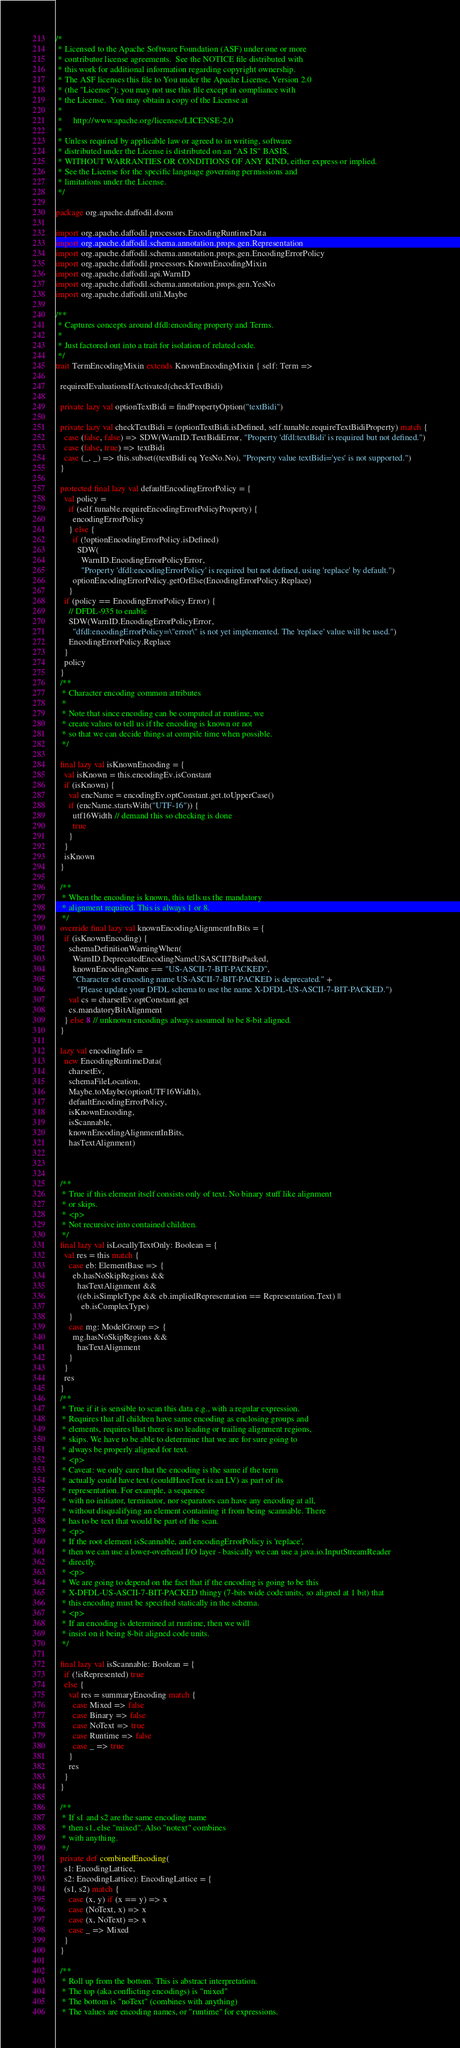<code> <loc_0><loc_0><loc_500><loc_500><_Scala_>/*
 * Licensed to the Apache Software Foundation (ASF) under one or more
 * contributor license agreements.  See the NOTICE file distributed with
 * this work for additional information regarding copyright ownership.
 * The ASF licenses this file to You under the Apache License, Version 2.0
 * (the "License"); you may not use this file except in compliance with
 * the License.  You may obtain a copy of the License at
 *
 *     http://www.apache.org/licenses/LICENSE-2.0
 *
 * Unless required by applicable law or agreed to in writing, software
 * distributed under the License is distributed on an "AS IS" BASIS,
 * WITHOUT WARRANTIES OR CONDITIONS OF ANY KIND, either express or implied.
 * See the License for the specific language governing permissions and
 * limitations under the License.
 */

package org.apache.daffodil.dsom

import org.apache.daffodil.processors.EncodingRuntimeData
import org.apache.daffodil.schema.annotation.props.gen.Representation
import org.apache.daffodil.schema.annotation.props.gen.EncodingErrorPolicy
import org.apache.daffodil.processors.KnownEncodingMixin
import org.apache.daffodil.api.WarnID
import org.apache.daffodil.schema.annotation.props.gen.YesNo
import org.apache.daffodil.util.Maybe

/**
 * Captures concepts around dfdl:encoding property and Terms.
 *
 * Just factored out into a trait for isolation of related code.
 */
trait TermEncodingMixin extends KnownEncodingMixin { self: Term =>

  requiredEvaluationsIfActivated(checkTextBidi)

  private lazy val optionTextBidi = findPropertyOption("textBidi")

  private lazy val checkTextBidi = (optionTextBidi.isDefined, self.tunable.requireTextBidiProperty) match {
    case (false, false) => SDW(WarnID.TextBidiError, "Property 'dfdl:textBidi' is required but not defined.")
    case (false, true) => textBidi
    case (_, _) => this.subset((textBidi eq YesNo.No), "Property value textBidi='yes' is not supported.")
  }

  protected final lazy val defaultEncodingErrorPolicy = {
    val policy =
      if (self.tunable.requireEncodingErrorPolicyProperty) {
        encodingErrorPolicy
      } else {
        if (!optionEncodingErrorPolicy.isDefined)
          SDW(
            WarnID.EncodingErrorPolicyError,
            "Property 'dfdl:encodingErrorPolicy' is required but not defined, using 'replace' by default.")
        optionEncodingErrorPolicy.getOrElse(EncodingErrorPolicy.Replace)
      }
    if (policy == EncodingErrorPolicy.Error) {
      // DFDL-935 to enable
      SDW(WarnID.EncodingErrorPolicyError,
        "dfdl:encodingErrorPolicy=\"error\" is not yet implemented. The 'replace' value will be used.")
      EncodingErrorPolicy.Replace
    }
    policy
  }
  /**
   * Character encoding common attributes
   *
   * Note that since encoding can be computed at runtime, we
   * create values to tell us if the encoding is known or not
   * so that we can decide things at compile time when possible.
   */

  final lazy val isKnownEncoding = {
    val isKnown = this.encodingEv.isConstant
    if (isKnown) {
      val encName = encodingEv.optConstant.get.toUpperCase()
      if (encName.startsWith("UTF-16")) {
        utf16Width // demand this so checking is done
        true
      }
    }
    isKnown
  }

  /**
   * When the encoding is known, this tells us the mandatory
   * alignment required. This is always 1 or 8.
   */
  override final lazy val knownEncodingAlignmentInBits = {
    if (isKnownEncoding) {
      schemaDefinitionWarningWhen(
        WarnID.DeprecatedEncodingNameUSASCII7BitPacked,
        knownEncodingName == "US-ASCII-7-BIT-PACKED",
        "Character set encoding name US-ASCII-7-BIT-PACKED is deprecated." +
          "Please update your DFDL schema to use the name X-DFDL-US-ASCII-7-BIT-PACKED.")
      val cs = charsetEv.optConstant.get
      cs.mandatoryBitAlignment
    } else 8 // unknown encodings always assumed to be 8-bit aligned.
  }

  lazy val encodingInfo =
    new EncodingRuntimeData(
      charsetEv,
      schemaFileLocation,
      Maybe.toMaybe(optionUTF16Width),
      defaultEncodingErrorPolicy,
      isKnownEncoding,
      isScannable,
      knownEncodingAlignmentInBits,
      hasTextAlignment)



  /**
   * True if this element itself consists only of text. No binary stuff like alignment
   * or skips.
   * <p>
   * Not recursive into contained children.
   */
  final lazy val isLocallyTextOnly: Boolean = {
    val res = this match {
      case eb: ElementBase => {
        eb.hasNoSkipRegions &&
          hasTextAlignment &&
          ((eb.isSimpleType && eb.impliedRepresentation == Representation.Text) ||
            eb.isComplexType)
      }
      case mg: ModelGroup => {
        mg.hasNoSkipRegions &&
          hasTextAlignment
      }
    }
    res
  }
  /**
   * True if it is sensible to scan this data e.g., with a regular expression.
   * Requires that all children have same encoding as enclosing groups and
   * elements, requires that there is no leading or trailing alignment regions,
   * skips. We have to be able to determine that we are for sure going to
   * always be properly aligned for text.
   * <p>
   * Caveat: we only care that the encoding is the same if the term
   * actually could have text (couldHaveText is an LV) as part of its
   * representation. For example, a sequence
   * with no initiator, terminator, nor separators can have any encoding at all,
   * without disqualifying an element containing it from being scannable. There
   * has to be text that would be part of the scan.
   * <p>
   * If the root element isScannable, and encodingErrorPolicy is 'replace',
   * then we can use a lower-overhead I/O layer - basically we can use a java.io.InputStreamReader
   * directly.
   * <p>
   * We are going to depend on the fact that if the encoding is going to be this
   * X-DFDL-US-ASCII-7-BIT-PACKED thingy (7-bits wide code units, so aligned at 1 bit) that
   * this encoding must be specified statically in the schema.
   * <p>
   * If an encoding is determined at runtime, then we will
   * insist on it being 8-bit aligned code units.
   */

  final lazy val isScannable: Boolean = {
    if (!isRepresented) true
    else {
      val res = summaryEncoding match {
        case Mixed => false
        case Binary => false
        case NoText => true
        case Runtime => false
        case _ => true
      }
      res
    }
  }

  /**
   * If s1 and s2 are the same encoding name
   * then s1, else "mixed". Also "notext" combines
   * with anything.
   */
  private def combinedEncoding(
    s1: EncodingLattice,
    s2: EncodingLattice): EncodingLattice = {
    (s1, s2) match {
      case (x, y) if (x == y) => x
      case (NoText, x) => x
      case (x, NoText) => x
      case _ => Mixed
    }
  }

  /**
   * Roll up from the bottom. This is abstract interpretation.
   * The top (aka conflicting encodings) is "mixed"
   * The bottom is "noText" (combines with anything)
   * The values are encoding names, or "runtime" for expressions.</code> 